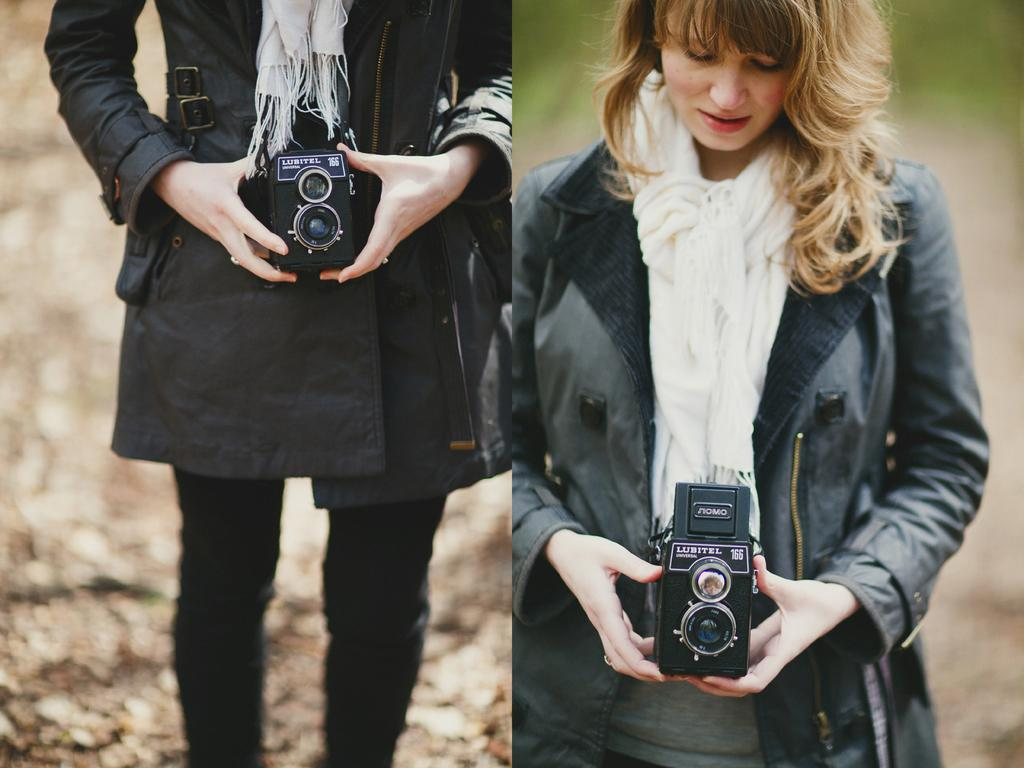What type of image is shown in the picture? The image is a collage. Can you describe the person in the image? There is a woman in the image. What is the woman doing in the image? The woman is standing. What is the woman holding in her hands? The woman is holding a camera in her hands. What is the woman wearing in the image? The woman is wearing a black jacket. What is the color of the woman's hair? The woman's hair color is light brown. How many family members are present in the image? There is no family present in the image; it only features a woman holding a camera. What type of event is the woman attending in the image? There is no event mentioned or depicted in the image; it is a simple image of a woman holding a camera. 